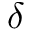<formula> <loc_0><loc_0><loc_500><loc_500>\delta</formula> 